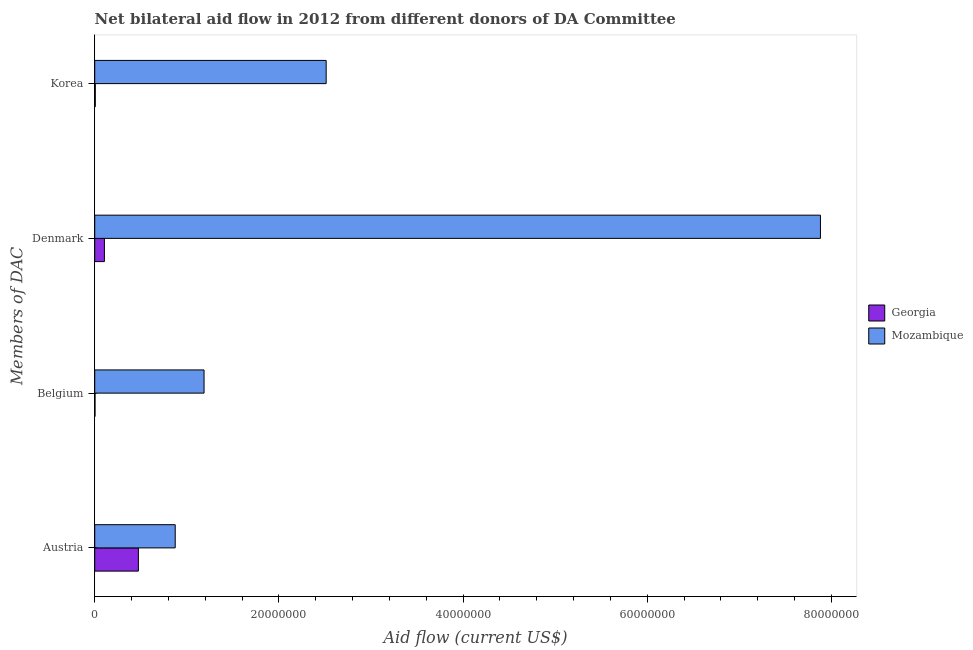How many different coloured bars are there?
Make the answer very short. 2. Are the number of bars on each tick of the Y-axis equal?
Your answer should be compact. Yes. How many bars are there on the 1st tick from the bottom?
Your response must be concise. 2. What is the amount of aid given by belgium in Mozambique?
Ensure brevity in your answer.  1.19e+07. Across all countries, what is the maximum amount of aid given by austria?
Provide a short and direct response. 8.74e+06. Across all countries, what is the minimum amount of aid given by austria?
Provide a succinct answer. 4.74e+06. In which country was the amount of aid given by belgium maximum?
Provide a short and direct response. Mozambique. In which country was the amount of aid given by korea minimum?
Your answer should be compact. Georgia. What is the total amount of aid given by korea in the graph?
Your answer should be very brief. 2.52e+07. What is the difference between the amount of aid given by belgium in Georgia and that in Mozambique?
Offer a very short reply. -1.18e+07. What is the difference between the amount of aid given by austria in Georgia and the amount of aid given by belgium in Mozambique?
Provide a short and direct response. -7.13e+06. What is the average amount of aid given by austria per country?
Your response must be concise. 6.74e+06. What is the difference between the amount of aid given by belgium and amount of aid given by denmark in Georgia?
Offer a terse response. -1.02e+06. What is the ratio of the amount of aid given by belgium in Georgia to that in Mozambique?
Ensure brevity in your answer.  0. What is the difference between the highest and the second highest amount of aid given by belgium?
Ensure brevity in your answer.  1.18e+07. What is the difference between the highest and the lowest amount of aid given by austria?
Make the answer very short. 4.00e+06. In how many countries, is the amount of aid given by korea greater than the average amount of aid given by korea taken over all countries?
Make the answer very short. 1. What does the 2nd bar from the top in Belgium represents?
Ensure brevity in your answer.  Georgia. What does the 1st bar from the bottom in Austria represents?
Your response must be concise. Georgia. Is it the case that in every country, the sum of the amount of aid given by austria and amount of aid given by belgium is greater than the amount of aid given by denmark?
Provide a short and direct response. No. Are all the bars in the graph horizontal?
Provide a short and direct response. Yes. What is the difference between two consecutive major ticks on the X-axis?
Offer a terse response. 2.00e+07. Where does the legend appear in the graph?
Offer a very short reply. Center right. What is the title of the graph?
Your response must be concise. Net bilateral aid flow in 2012 from different donors of DA Committee. What is the label or title of the X-axis?
Your answer should be compact. Aid flow (current US$). What is the label or title of the Y-axis?
Offer a terse response. Members of DAC. What is the Aid flow (current US$) in Georgia in Austria?
Offer a very short reply. 4.74e+06. What is the Aid flow (current US$) of Mozambique in Austria?
Your answer should be very brief. 8.74e+06. What is the Aid flow (current US$) of Mozambique in Belgium?
Offer a terse response. 1.19e+07. What is the Aid flow (current US$) in Georgia in Denmark?
Your answer should be compact. 1.05e+06. What is the Aid flow (current US$) of Mozambique in Denmark?
Keep it short and to the point. 7.88e+07. What is the Aid flow (current US$) in Mozambique in Korea?
Make the answer very short. 2.51e+07. Across all Members of DAC, what is the maximum Aid flow (current US$) of Georgia?
Provide a succinct answer. 4.74e+06. Across all Members of DAC, what is the maximum Aid flow (current US$) of Mozambique?
Offer a very short reply. 7.88e+07. Across all Members of DAC, what is the minimum Aid flow (current US$) of Mozambique?
Give a very brief answer. 8.74e+06. What is the total Aid flow (current US$) of Georgia in the graph?
Make the answer very short. 5.88e+06. What is the total Aid flow (current US$) of Mozambique in the graph?
Make the answer very short. 1.25e+08. What is the difference between the Aid flow (current US$) in Georgia in Austria and that in Belgium?
Provide a short and direct response. 4.71e+06. What is the difference between the Aid flow (current US$) of Mozambique in Austria and that in Belgium?
Your answer should be compact. -3.13e+06. What is the difference between the Aid flow (current US$) in Georgia in Austria and that in Denmark?
Make the answer very short. 3.69e+06. What is the difference between the Aid flow (current US$) of Mozambique in Austria and that in Denmark?
Keep it short and to the point. -7.01e+07. What is the difference between the Aid flow (current US$) in Georgia in Austria and that in Korea?
Keep it short and to the point. 4.68e+06. What is the difference between the Aid flow (current US$) in Mozambique in Austria and that in Korea?
Ensure brevity in your answer.  -1.64e+07. What is the difference between the Aid flow (current US$) of Georgia in Belgium and that in Denmark?
Keep it short and to the point. -1.02e+06. What is the difference between the Aid flow (current US$) in Mozambique in Belgium and that in Denmark?
Keep it short and to the point. -6.69e+07. What is the difference between the Aid flow (current US$) of Mozambique in Belgium and that in Korea?
Make the answer very short. -1.33e+07. What is the difference between the Aid flow (current US$) in Georgia in Denmark and that in Korea?
Offer a very short reply. 9.90e+05. What is the difference between the Aid flow (current US$) in Mozambique in Denmark and that in Korea?
Your answer should be very brief. 5.37e+07. What is the difference between the Aid flow (current US$) of Georgia in Austria and the Aid flow (current US$) of Mozambique in Belgium?
Your answer should be compact. -7.13e+06. What is the difference between the Aid flow (current US$) of Georgia in Austria and the Aid flow (current US$) of Mozambique in Denmark?
Give a very brief answer. -7.41e+07. What is the difference between the Aid flow (current US$) of Georgia in Austria and the Aid flow (current US$) of Mozambique in Korea?
Your answer should be compact. -2.04e+07. What is the difference between the Aid flow (current US$) of Georgia in Belgium and the Aid flow (current US$) of Mozambique in Denmark?
Offer a very short reply. -7.88e+07. What is the difference between the Aid flow (current US$) of Georgia in Belgium and the Aid flow (current US$) of Mozambique in Korea?
Offer a terse response. -2.51e+07. What is the difference between the Aid flow (current US$) in Georgia in Denmark and the Aid flow (current US$) in Mozambique in Korea?
Provide a short and direct response. -2.41e+07. What is the average Aid flow (current US$) of Georgia per Members of DAC?
Your answer should be very brief. 1.47e+06. What is the average Aid flow (current US$) of Mozambique per Members of DAC?
Ensure brevity in your answer.  3.11e+07. What is the difference between the Aid flow (current US$) in Georgia and Aid flow (current US$) in Mozambique in Belgium?
Give a very brief answer. -1.18e+07. What is the difference between the Aid flow (current US$) in Georgia and Aid flow (current US$) in Mozambique in Denmark?
Make the answer very short. -7.78e+07. What is the difference between the Aid flow (current US$) in Georgia and Aid flow (current US$) in Mozambique in Korea?
Ensure brevity in your answer.  -2.51e+07. What is the ratio of the Aid flow (current US$) of Georgia in Austria to that in Belgium?
Offer a terse response. 158. What is the ratio of the Aid flow (current US$) of Mozambique in Austria to that in Belgium?
Your answer should be compact. 0.74. What is the ratio of the Aid flow (current US$) in Georgia in Austria to that in Denmark?
Your answer should be very brief. 4.51. What is the ratio of the Aid flow (current US$) in Mozambique in Austria to that in Denmark?
Make the answer very short. 0.11. What is the ratio of the Aid flow (current US$) of Georgia in Austria to that in Korea?
Make the answer very short. 79. What is the ratio of the Aid flow (current US$) in Mozambique in Austria to that in Korea?
Provide a succinct answer. 0.35. What is the ratio of the Aid flow (current US$) of Georgia in Belgium to that in Denmark?
Your response must be concise. 0.03. What is the ratio of the Aid flow (current US$) of Mozambique in Belgium to that in Denmark?
Offer a very short reply. 0.15. What is the ratio of the Aid flow (current US$) in Georgia in Belgium to that in Korea?
Offer a terse response. 0.5. What is the ratio of the Aid flow (current US$) in Mozambique in Belgium to that in Korea?
Provide a short and direct response. 0.47. What is the ratio of the Aid flow (current US$) of Mozambique in Denmark to that in Korea?
Ensure brevity in your answer.  3.14. What is the difference between the highest and the second highest Aid flow (current US$) of Georgia?
Keep it short and to the point. 3.69e+06. What is the difference between the highest and the second highest Aid flow (current US$) in Mozambique?
Make the answer very short. 5.37e+07. What is the difference between the highest and the lowest Aid flow (current US$) of Georgia?
Offer a terse response. 4.71e+06. What is the difference between the highest and the lowest Aid flow (current US$) of Mozambique?
Offer a very short reply. 7.01e+07. 